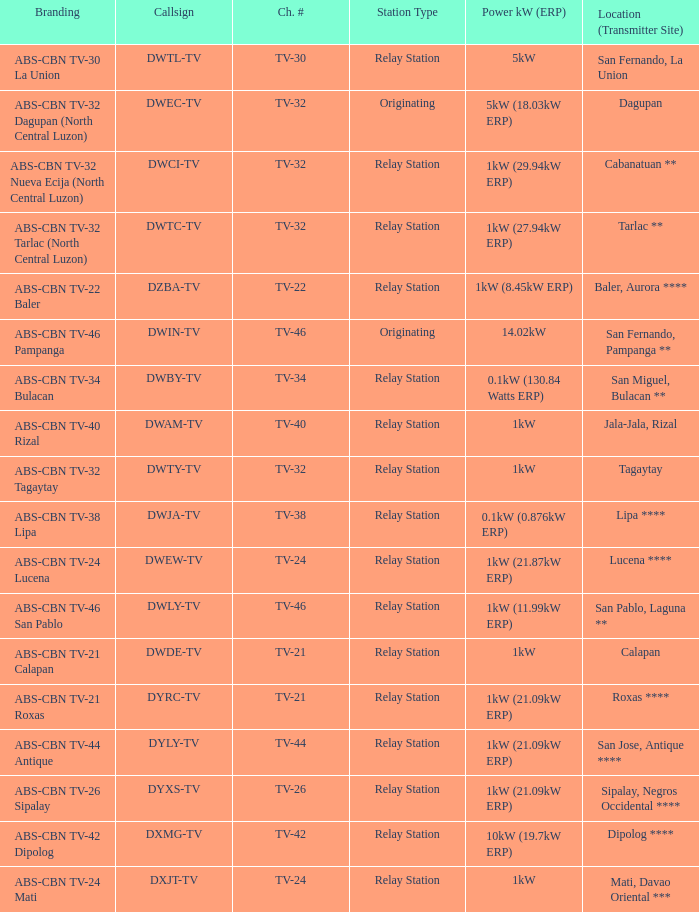What is the branding of the callsign DWCI-TV? ABS-CBN TV-32 Nueva Ecija (North Central Luzon). 